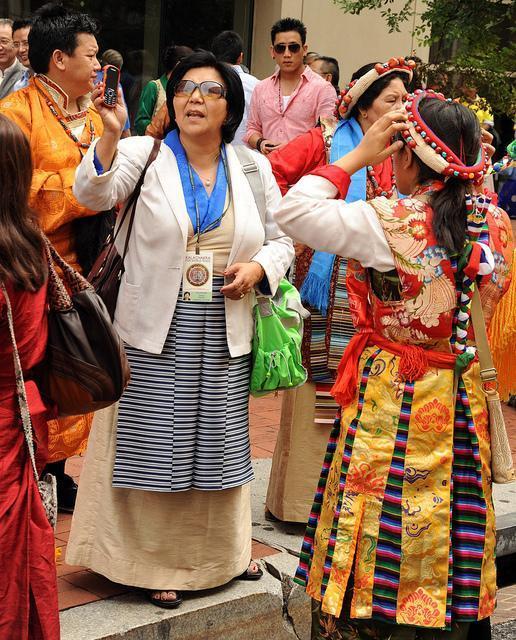How many women are in the photo?
Give a very brief answer. 4. How many people are visible?
Give a very brief answer. 6. How many handbags are in the photo?
Give a very brief answer. 3. How many characters on the digitized reader board on the top front of the bus are numerals?
Give a very brief answer. 0. 